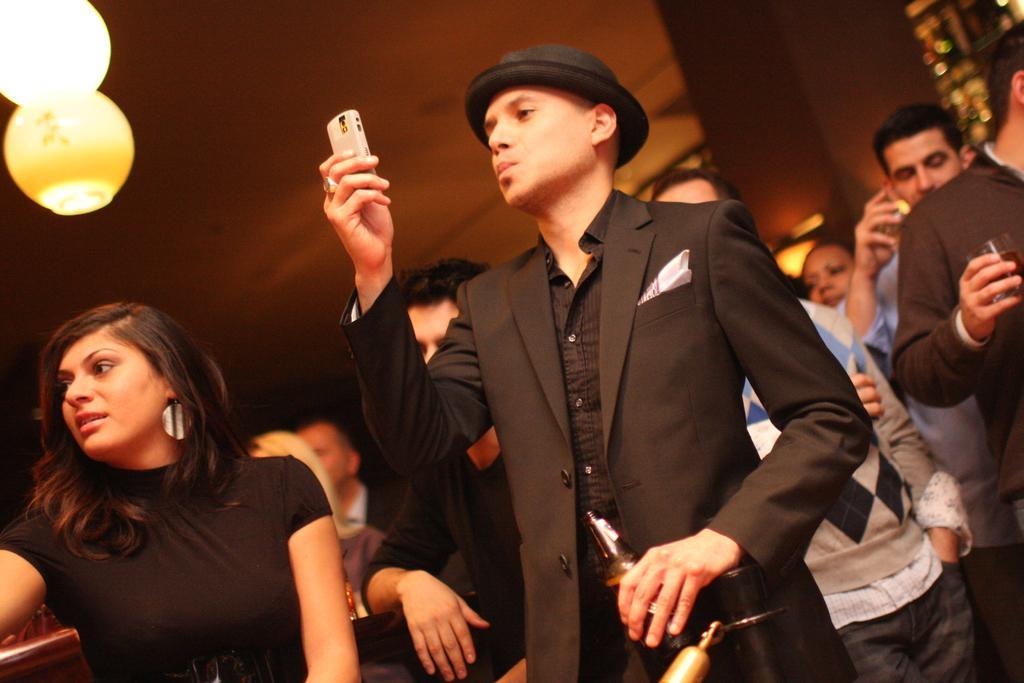Could you give a brief overview of what you see in this image? In this image we can see group of persons standing on the floor. One person is wearing a black coat and a hat is holding a mobile in his hand and a bottle in the other hand. In the background. we can see group of lights. 